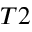Convert formula to latex. <formula><loc_0><loc_0><loc_500><loc_500>T 2</formula> 